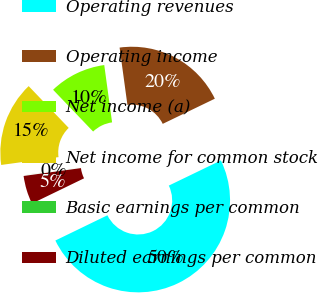Convert chart to OTSL. <chart><loc_0><loc_0><loc_500><loc_500><pie_chart><fcel>Operating revenues<fcel>Operating income<fcel>Net income (a)<fcel>Net income for common stock<fcel>Basic earnings per common<fcel>Diluted earnings per common<nl><fcel>49.98%<fcel>20.0%<fcel>10.0%<fcel>15.0%<fcel>0.01%<fcel>5.01%<nl></chart> 